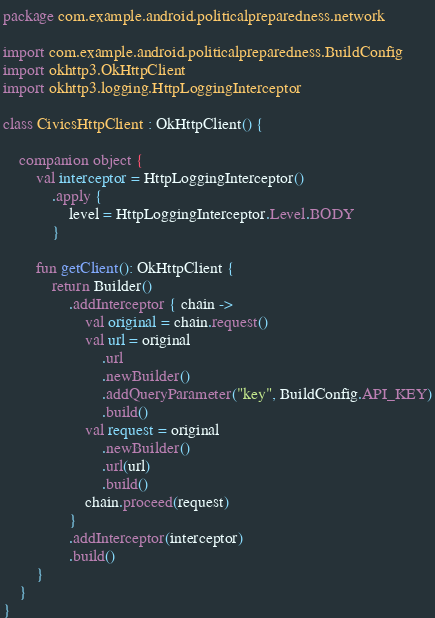<code> <loc_0><loc_0><loc_500><loc_500><_Kotlin_>package com.example.android.politicalpreparedness.network

import com.example.android.politicalpreparedness.BuildConfig
import okhttp3.OkHttpClient
import okhttp3.logging.HttpLoggingInterceptor

class CivicsHttpClient : OkHttpClient() {

    companion object {
        val interceptor = HttpLoggingInterceptor()
            .apply {
                level = HttpLoggingInterceptor.Level.BODY
            }

        fun getClient(): OkHttpClient {
            return Builder()
                .addInterceptor { chain ->
                    val original = chain.request()
                    val url = original
                        .url
                        .newBuilder()
                        .addQueryParameter("key", BuildConfig.API_KEY)
                        .build()
                    val request = original
                        .newBuilder()
                        .url(url)
                        .build()
                    chain.proceed(request)
                }
                .addInterceptor(interceptor)
                .build()
        }
    }
}
</code> 